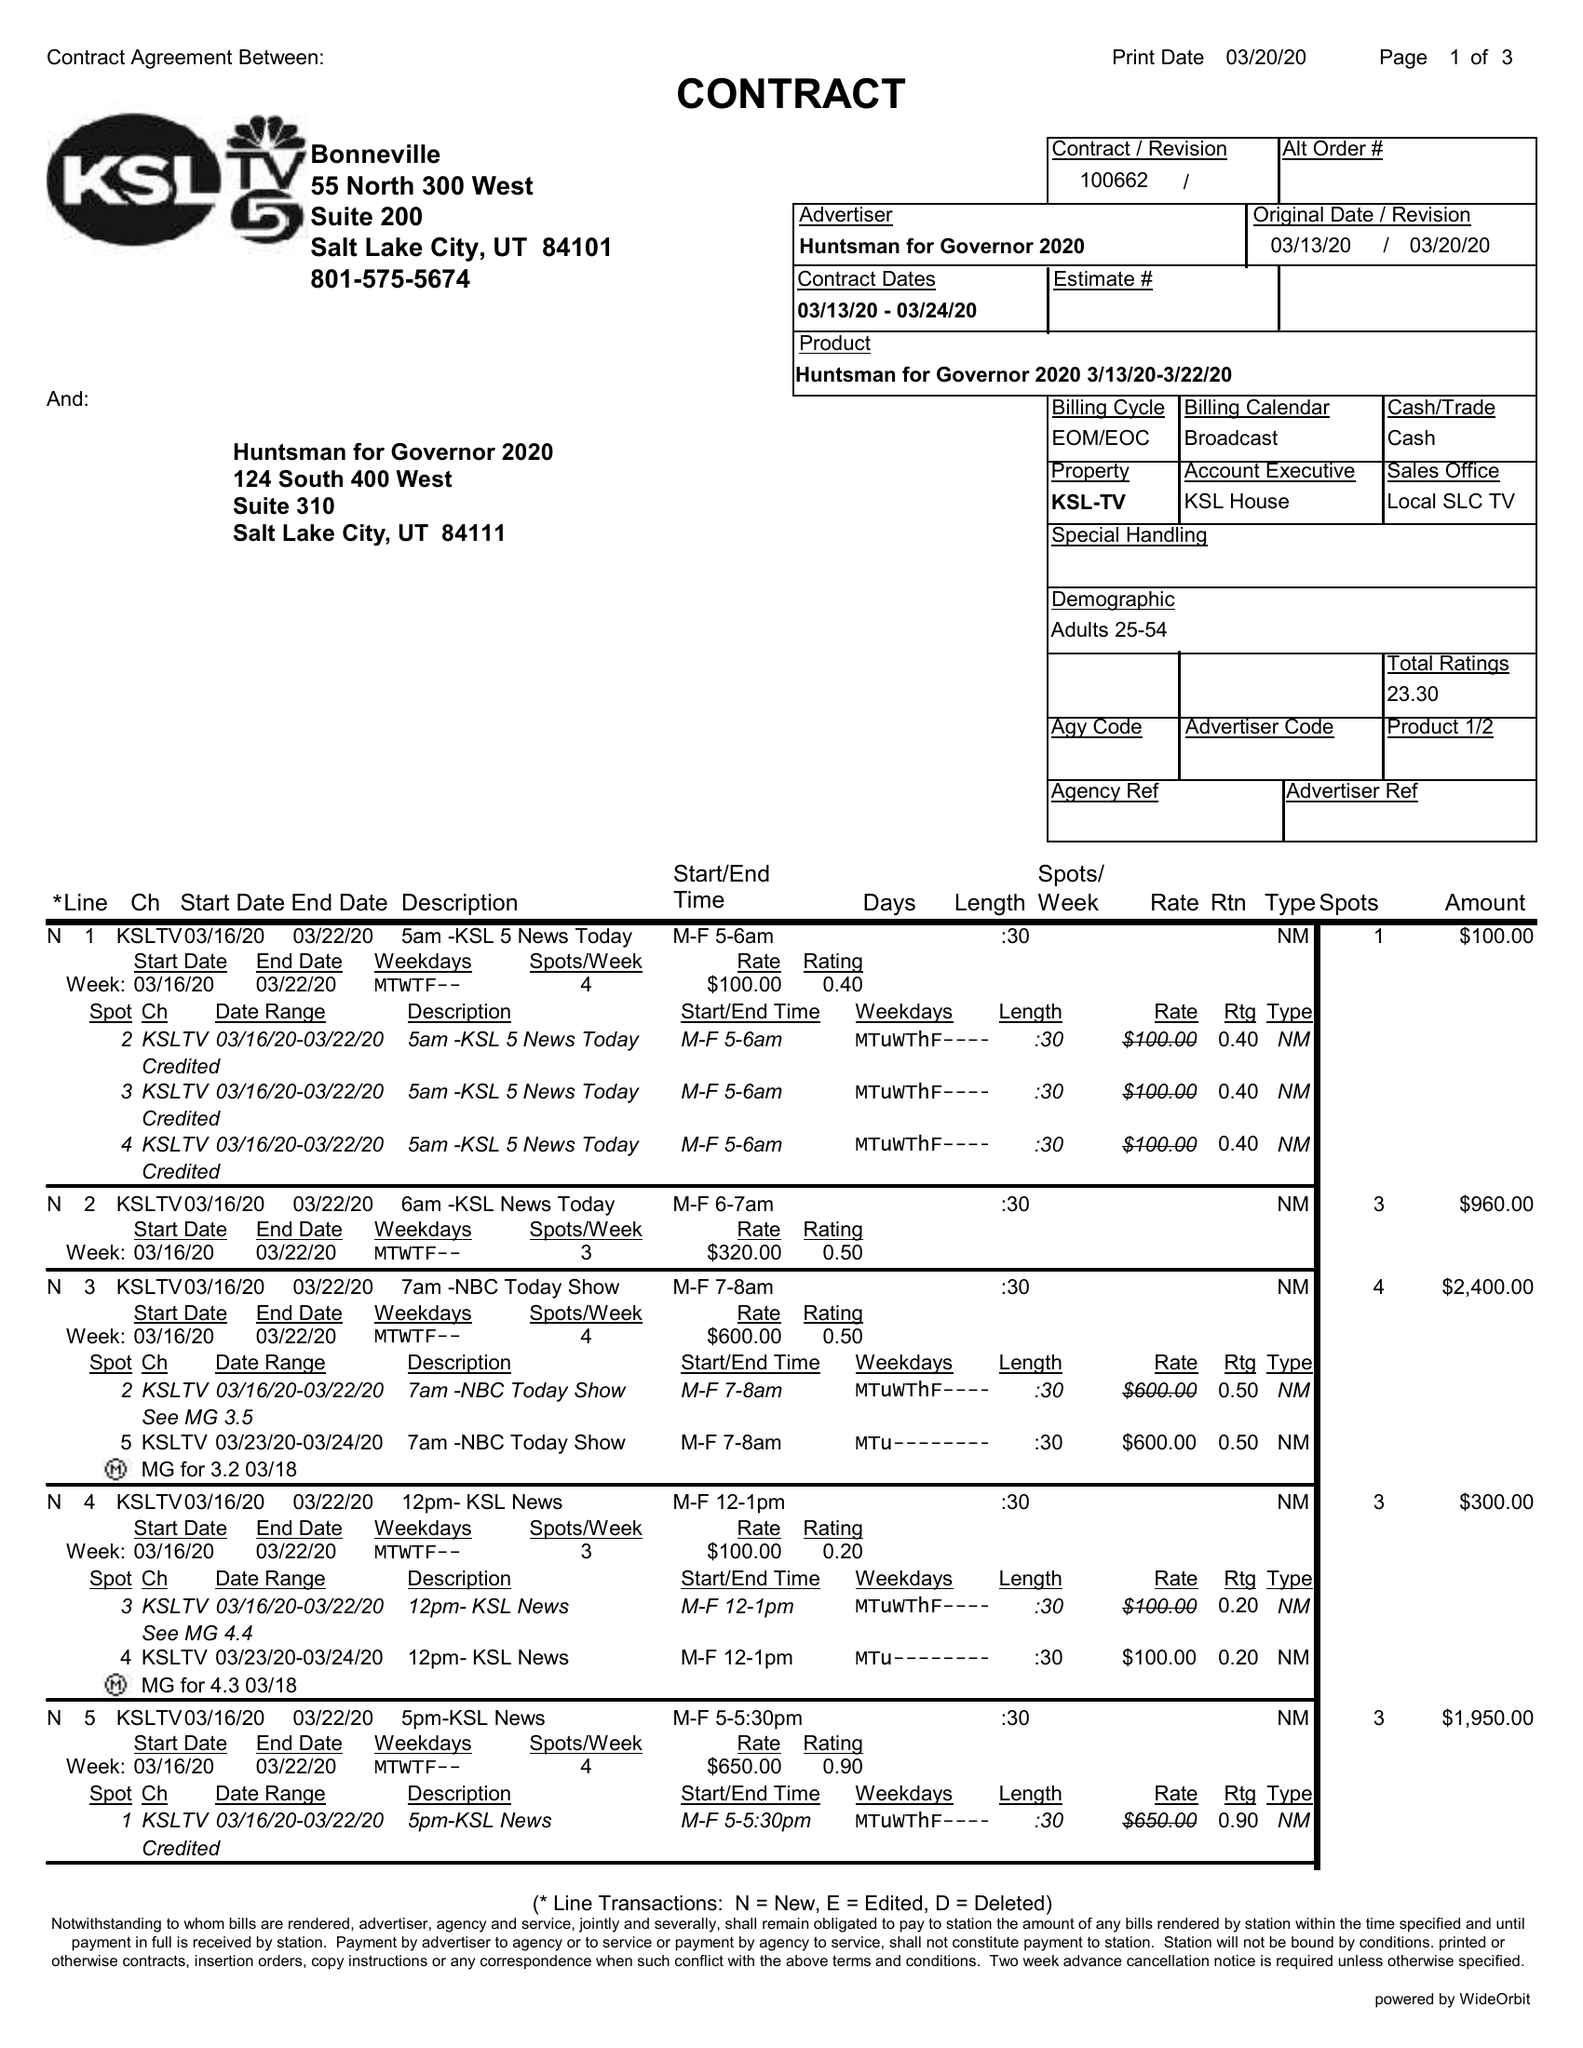What is the value for the gross_amount?
Answer the question using a single word or phrase. 23580.00 